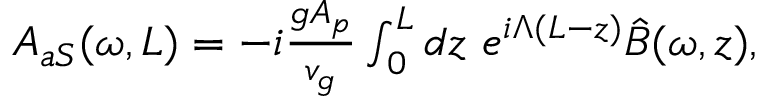<formula> <loc_0><loc_0><loc_500><loc_500>\begin{array} { r } { A _ { a S } ( \omega , L ) = - i \frac { g A _ { p } } { v _ { g } } \int _ { 0 } ^ { L } d z \ e ^ { i \Lambda ( L - z ) } \hat { B } ( \omega , z ) , } \end{array}</formula> 